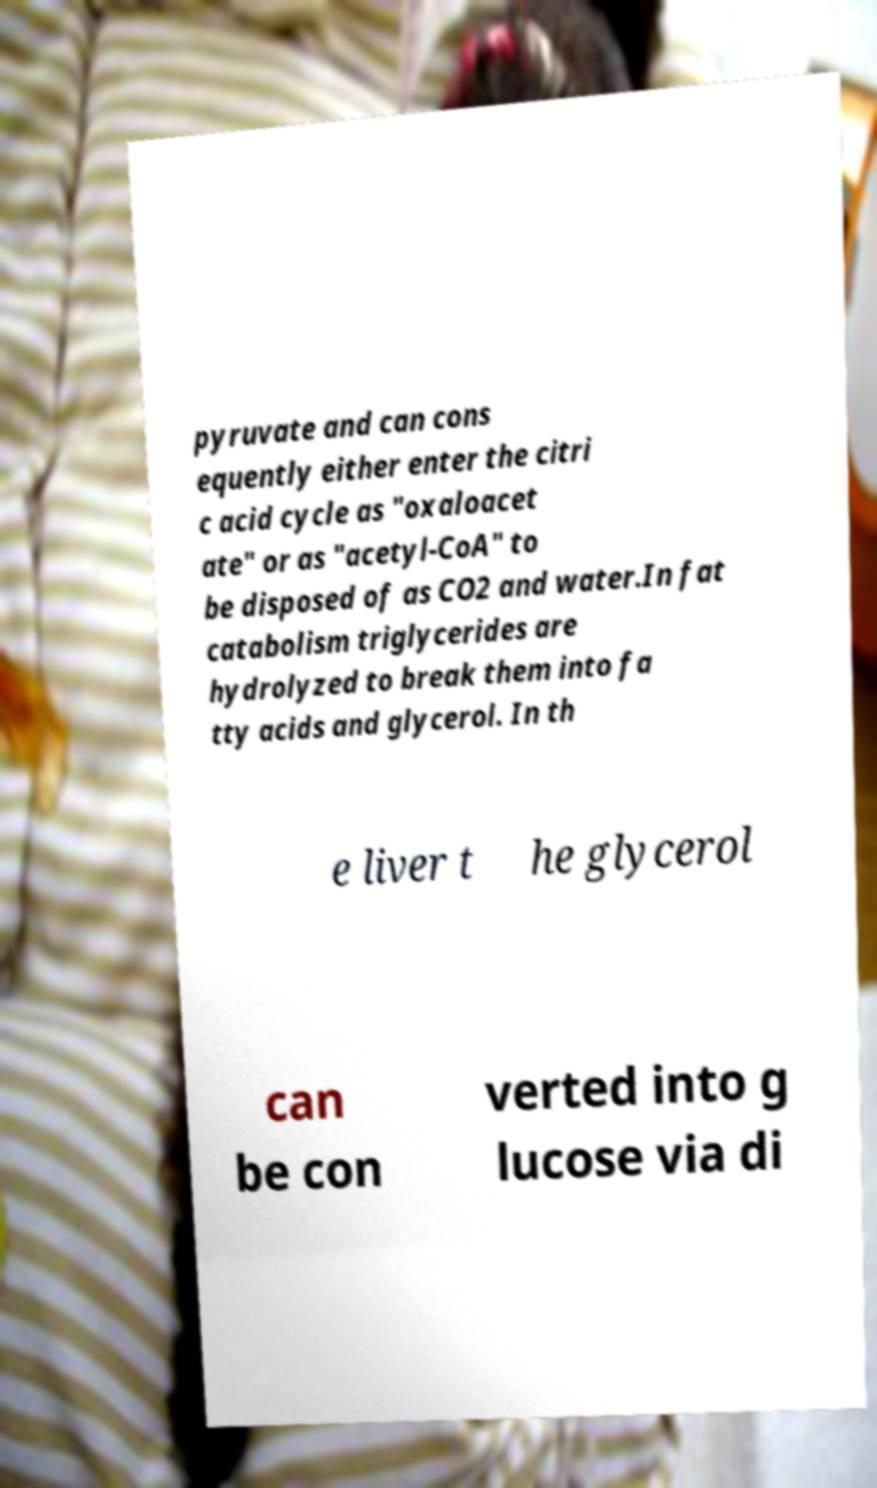What messages or text are displayed in this image? I need them in a readable, typed format. pyruvate and can cons equently either enter the citri c acid cycle as "oxaloacet ate" or as "acetyl-CoA" to be disposed of as CO2 and water.In fat catabolism triglycerides are hydrolyzed to break them into fa tty acids and glycerol. In th e liver t he glycerol can be con verted into g lucose via di 